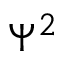Convert formula to latex. <formula><loc_0><loc_0><loc_500><loc_500>\Psi ^ { 2 }</formula> 